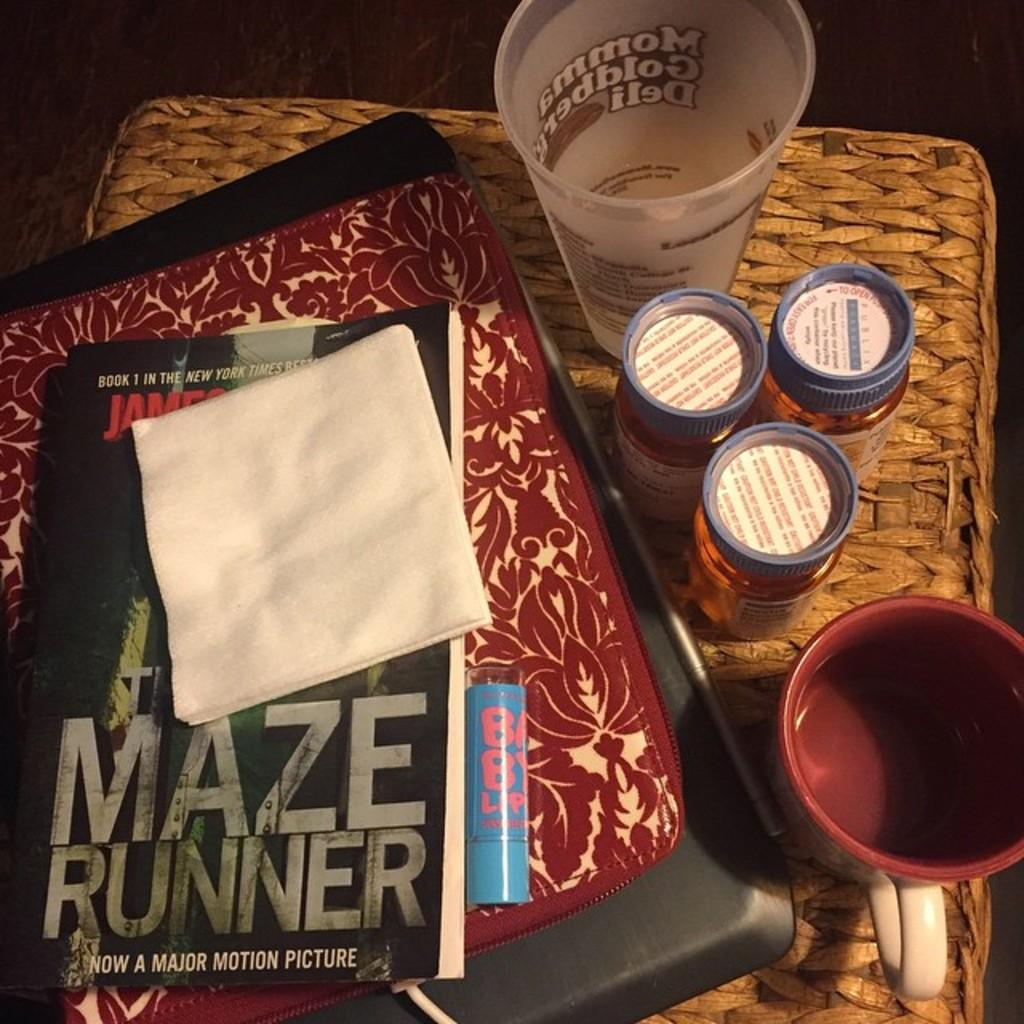<image>
Create a compact narrative representing the image presented. Someone has placed some white napkins on top of Maze Runner. 